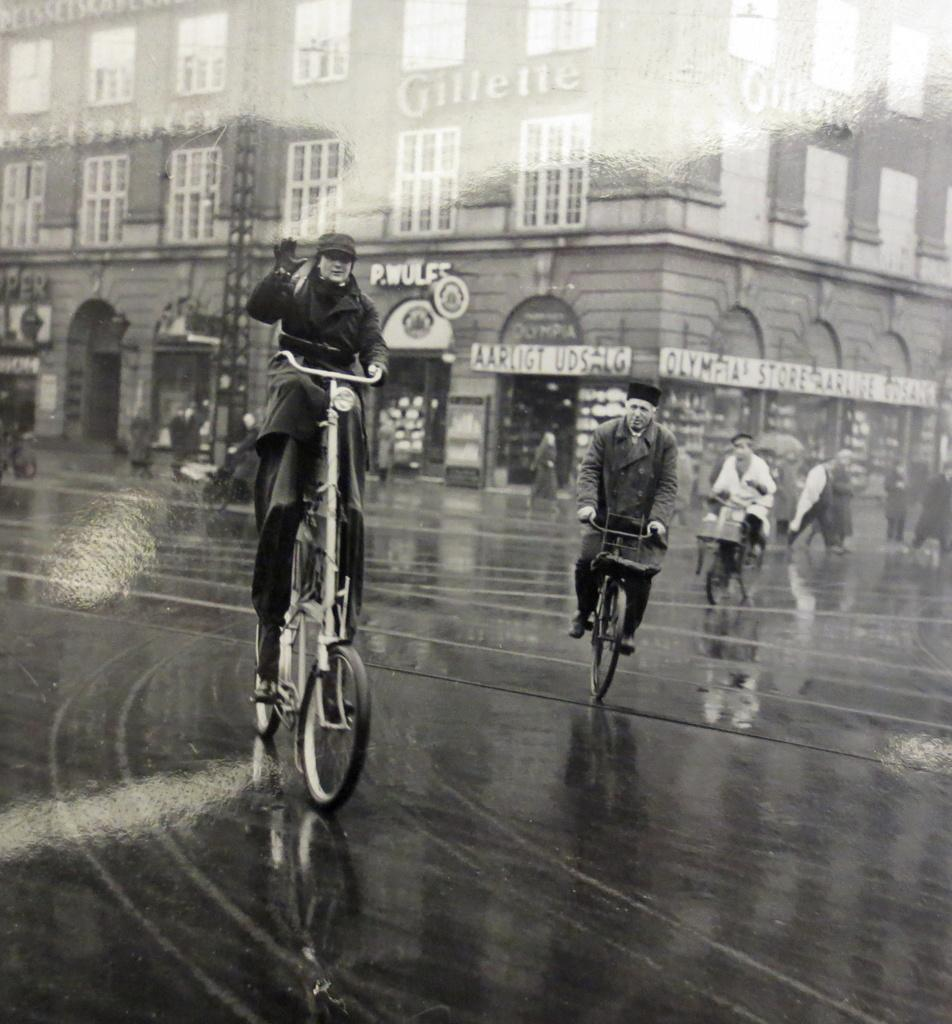What are the people in the image doing? The people in the image are riding bicycles on a road. Can you describe the clothing of one of the individuals? A woman is wearing a cap in the image. What can be seen in the background of the image? There is a building with windows in the background. What is attached to the building? There are boards on the building. How many trees are visible in the image? There are no trees visible in the image; it features people riding bicycles on a road with a building in the background. Can you tell me the name of the boy in the image? There is no boy present in the image; it features people riding bicycles, and one of them is a woman wearing a cap. 